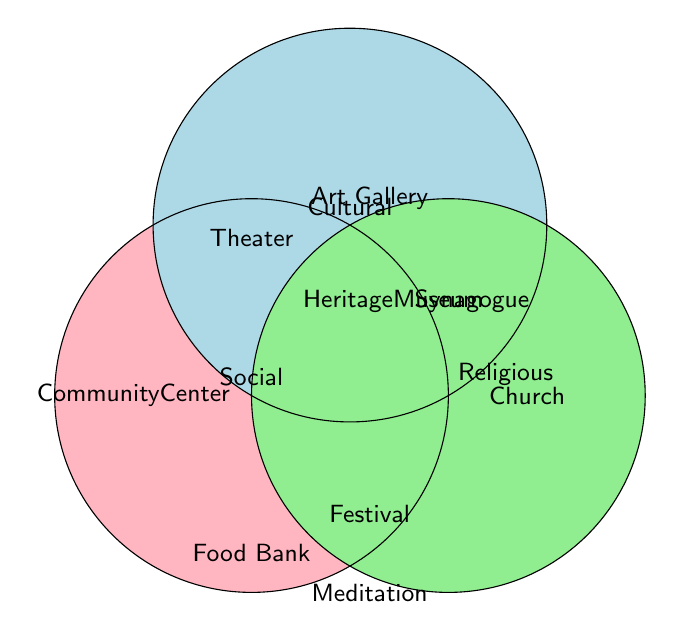What three categories are represented in this Venn Diagram? The Venn Diagram visually separates three different categories labeled "Social," "Cultural," and "Religious." Each category is represented using a unique color.
Answer: Social, Cultural, Religious What color represents the "Social" organizations? The circle labeled "Social" is filled with a pink color.
Answer: Pink How many organizations are listed under "Religious"? The "Religious" circle has five organizations listed: Local Church, Synagogue, Mosque, Temple, Interfaith Council, Prayer Group, and Meditation Center.
Answer: Seven How many organizations are listed in total across all categories? By counting all unique organizations listed in "Social" (7), "Cultural" (7), and "Religious" (7), we get a total of 21 organizations.
Answer: 21 How many organizations are shared between "Social" and "Cultural"? The top part of the Venn Diagram shows overlapping areas which represent shared organizations. However, there are no organizations explicitly marked as shared in this Venn Diagram.
Answer: 0 Which category has more organizations, "Social" or "Cultural"? Both "Social" and "Cultural" categories have the same number of organizations listed, which is 7 each.
Answer: Equal Which has fewer organizations, "Cultural" or "Religious"? By counting the number of organizations listed, we can see that both "Cultural" and "Religious" categories have the same count, which is 7 organizations each.
Answer: Equal Are there any organizations that belong to all three categories? The Venn Diagram does not show any organization that is listed in the overlapping area of all three circles.
Answer: No Are there organizations that are exclusive to just one category? Yes, each category in the Venn Diagram has exclusive organizations: "Social" has unique organizations like Community Center and Food Bank, "Cultural" has unique organizations like Art Gallery and Heritage Museum, and "Religious" has unique organizations like Local Church and Synagogue.
Answer: Yes Is there any overlap between "Cultural" and "Religious" organizations? By observing the diagram, there is no organization listed in the overlapping section between "Cultural" and "Religious."
Answer: No 